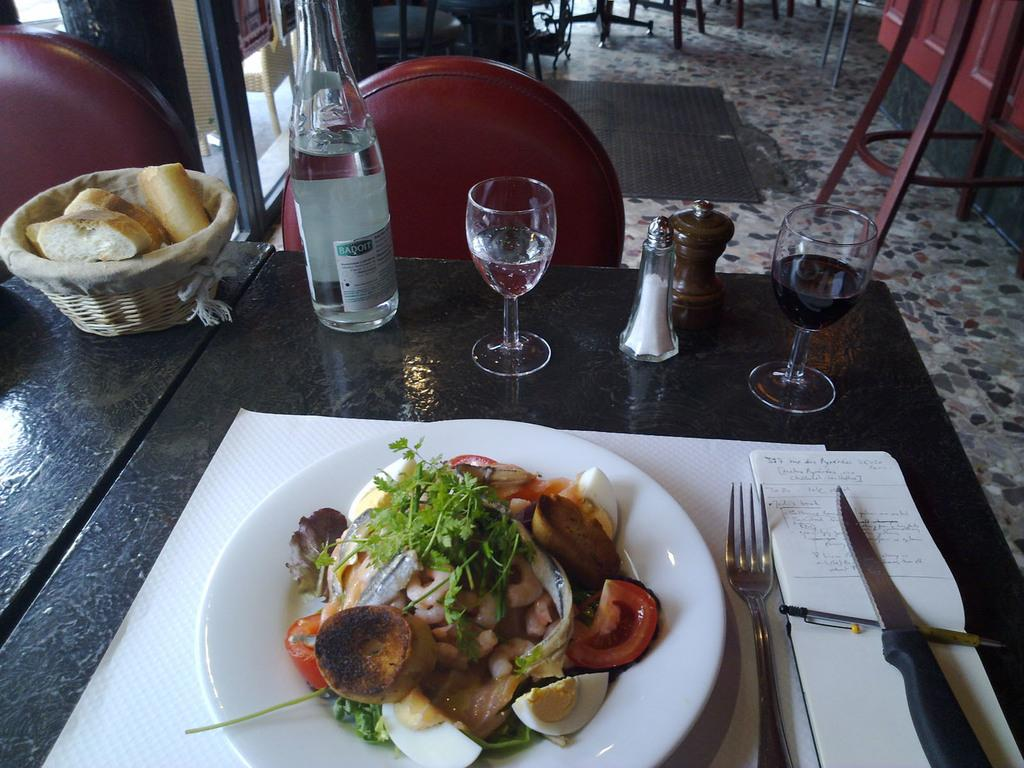What type of container is present in the image? There is a bottle in the image. What type of glasses are visible in the image? There are wine glasses in the image. What is on the plate in the image? There is food on a plate in the image. What utensils are present in the image? There is a fork and a knife in the image. What type of furniture is in the image? There are chairs in the image. Where is the basin located in the image? There is no basin present in the image. What type of pocket can be seen in the image? There is no pocket present in the image. 